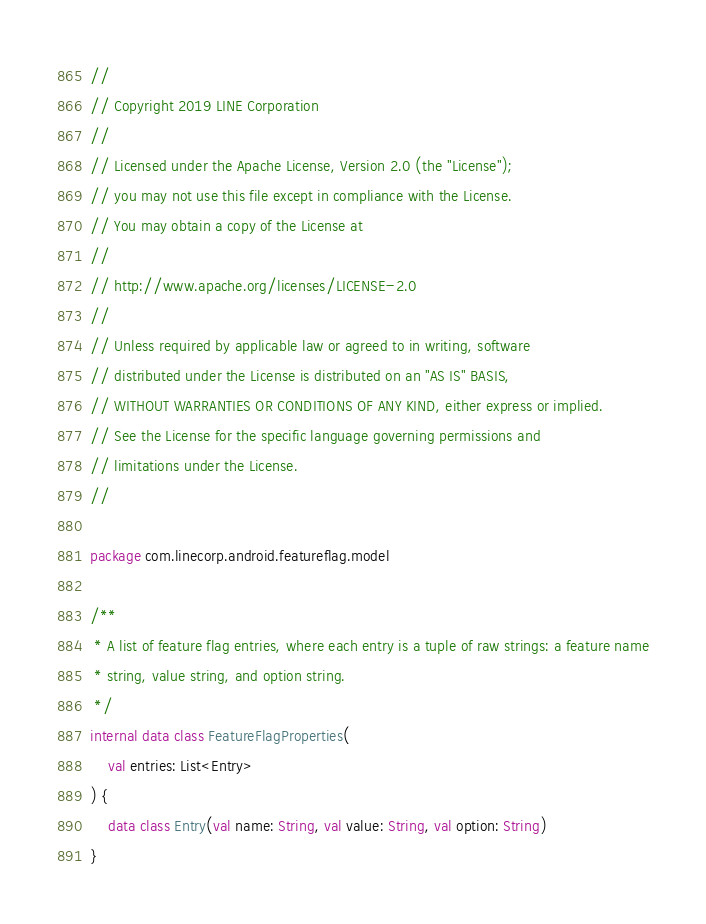Convert code to text. <code><loc_0><loc_0><loc_500><loc_500><_Kotlin_>//
// Copyright 2019 LINE Corporation
//
// Licensed under the Apache License, Version 2.0 (the "License");
// you may not use this file except in compliance with the License.
// You may obtain a copy of the License at
//
// http://www.apache.org/licenses/LICENSE-2.0
//
// Unless required by applicable law or agreed to in writing, software
// distributed under the License is distributed on an "AS IS" BASIS,
// WITHOUT WARRANTIES OR CONDITIONS OF ANY KIND, either express or implied.
// See the License for the specific language governing permissions and
// limitations under the License.
//

package com.linecorp.android.featureflag.model

/**
 * A list of feature flag entries, where each entry is a tuple of raw strings: a feature name
 * string, value string, and option string.
 */
internal data class FeatureFlagProperties(
    val entries: List<Entry>
) {
    data class Entry(val name: String, val value: String, val option: String)
}
</code> 